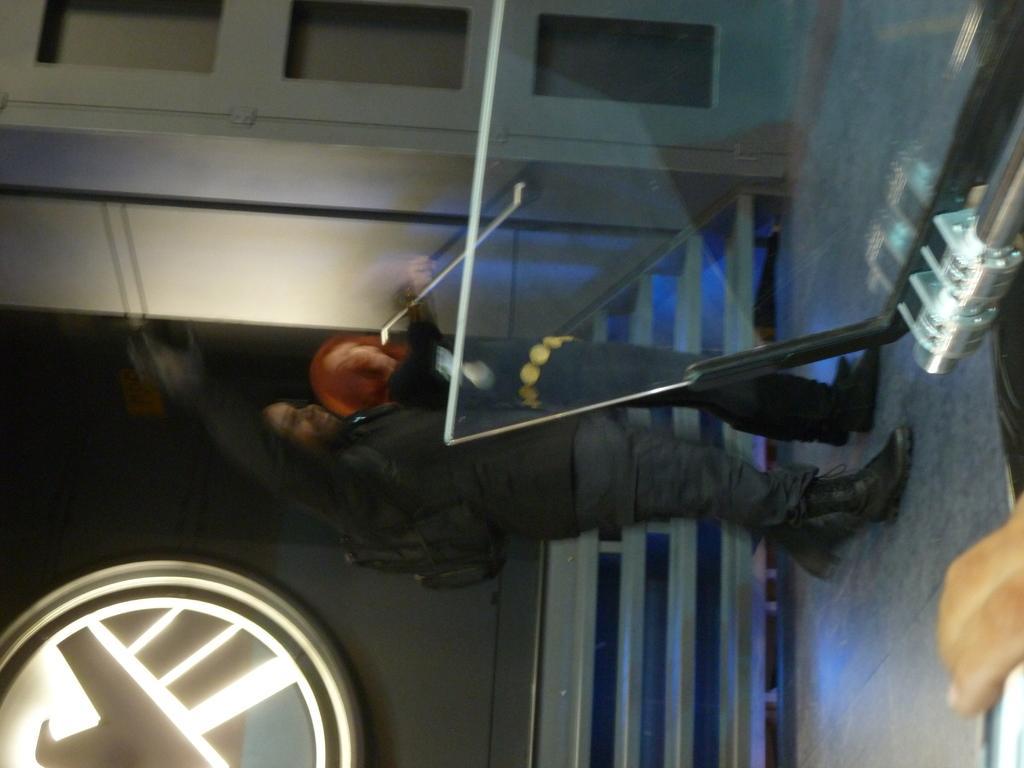How would you summarize this image in a sentence or two? In this picture there is a woman who is standing near to the wall. At the bottom I can see the railing. On the right I can see the glass stand. At the top I can see the door. 